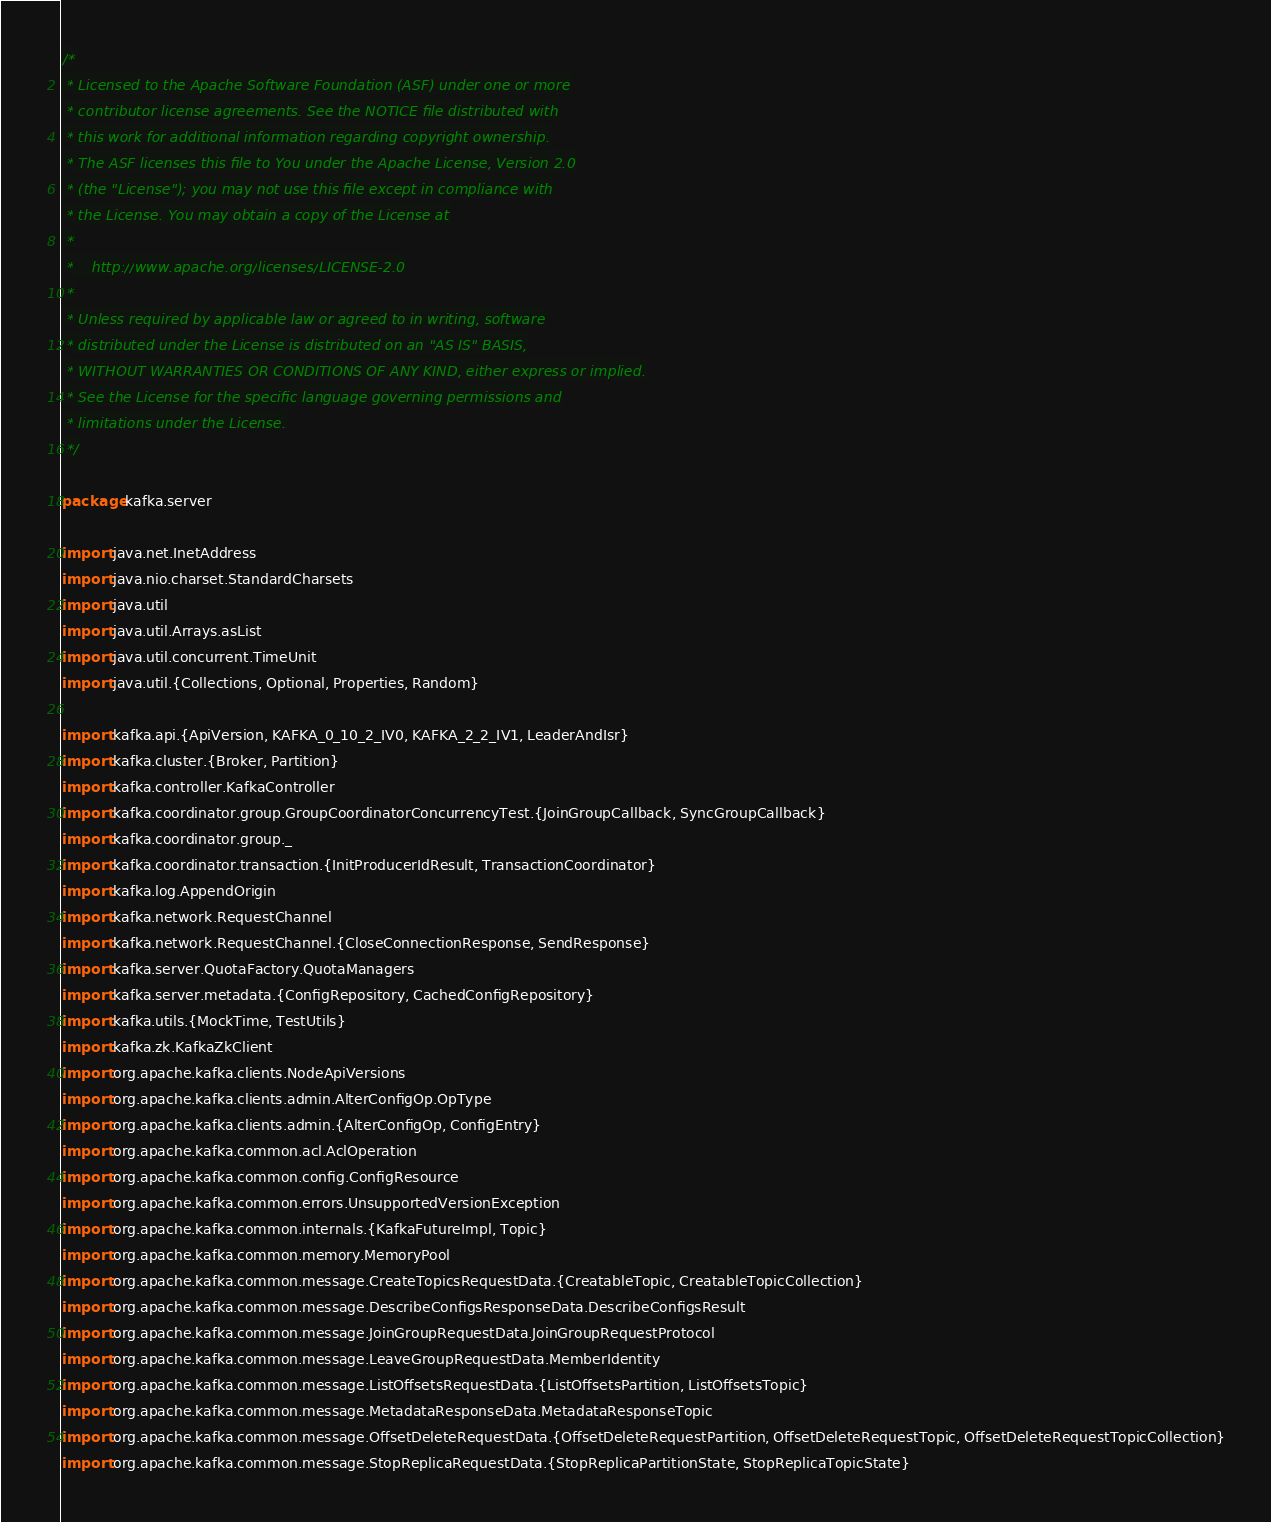<code> <loc_0><loc_0><loc_500><loc_500><_Scala_>/*
 * Licensed to the Apache Software Foundation (ASF) under one or more
 * contributor license agreements. See the NOTICE file distributed with
 * this work for additional information regarding copyright ownership.
 * The ASF licenses this file to You under the Apache License, Version 2.0
 * (the "License"); you may not use this file except in compliance with
 * the License. You may obtain a copy of the License at
 *
 *    http://www.apache.org/licenses/LICENSE-2.0
 *
 * Unless required by applicable law or agreed to in writing, software
 * distributed under the License is distributed on an "AS IS" BASIS,
 * WITHOUT WARRANTIES OR CONDITIONS OF ANY KIND, either express or implied.
 * See the License for the specific language governing permissions and
 * limitations under the License.
 */

package kafka.server

import java.net.InetAddress
import java.nio.charset.StandardCharsets
import java.util
import java.util.Arrays.asList
import java.util.concurrent.TimeUnit
import java.util.{Collections, Optional, Properties, Random}

import kafka.api.{ApiVersion, KAFKA_0_10_2_IV0, KAFKA_2_2_IV1, LeaderAndIsr}
import kafka.cluster.{Broker, Partition}
import kafka.controller.KafkaController
import kafka.coordinator.group.GroupCoordinatorConcurrencyTest.{JoinGroupCallback, SyncGroupCallback}
import kafka.coordinator.group._
import kafka.coordinator.transaction.{InitProducerIdResult, TransactionCoordinator}
import kafka.log.AppendOrigin
import kafka.network.RequestChannel
import kafka.network.RequestChannel.{CloseConnectionResponse, SendResponse}
import kafka.server.QuotaFactory.QuotaManagers
import kafka.server.metadata.{ConfigRepository, CachedConfigRepository}
import kafka.utils.{MockTime, TestUtils}
import kafka.zk.KafkaZkClient
import org.apache.kafka.clients.NodeApiVersions
import org.apache.kafka.clients.admin.AlterConfigOp.OpType
import org.apache.kafka.clients.admin.{AlterConfigOp, ConfigEntry}
import org.apache.kafka.common.acl.AclOperation
import org.apache.kafka.common.config.ConfigResource
import org.apache.kafka.common.errors.UnsupportedVersionException
import org.apache.kafka.common.internals.{KafkaFutureImpl, Topic}
import org.apache.kafka.common.memory.MemoryPool
import org.apache.kafka.common.message.CreateTopicsRequestData.{CreatableTopic, CreatableTopicCollection}
import org.apache.kafka.common.message.DescribeConfigsResponseData.DescribeConfigsResult
import org.apache.kafka.common.message.JoinGroupRequestData.JoinGroupRequestProtocol
import org.apache.kafka.common.message.LeaveGroupRequestData.MemberIdentity
import org.apache.kafka.common.message.ListOffsetsRequestData.{ListOffsetsPartition, ListOffsetsTopic}
import org.apache.kafka.common.message.MetadataResponseData.MetadataResponseTopic
import org.apache.kafka.common.message.OffsetDeleteRequestData.{OffsetDeleteRequestPartition, OffsetDeleteRequestTopic, OffsetDeleteRequestTopicCollection}
import org.apache.kafka.common.message.StopReplicaRequestData.{StopReplicaPartitionState, StopReplicaTopicState}</code> 